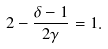Convert formula to latex. <formula><loc_0><loc_0><loc_500><loc_500>2 - \frac { \delta - 1 } { 2 \gamma } = 1 .</formula> 